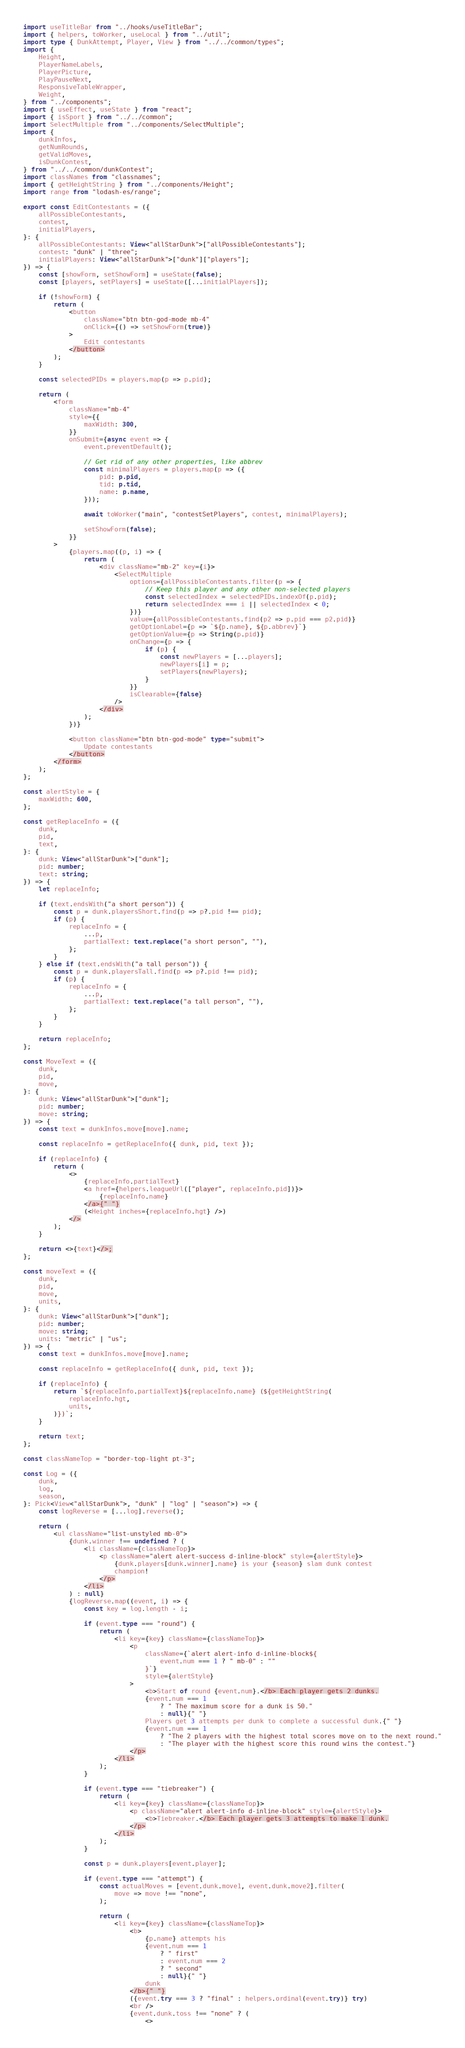<code> <loc_0><loc_0><loc_500><loc_500><_TypeScript_>import useTitleBar from "../hooks/useTitleBar";
import { helpers, toWorker, useLocal } from "../util";
import type { DunkAttempt, Player, View } from "../../common/types";
import {
	Height,
	PlayerNameLabels,
	PlayerPicture,
	PlayPauseNext,
	ResponsiveTableWrapper,
	Weight,
} from "../components";
import { useEffect, useState } from "react";
import { isSport } from "../../common";
import SelectMultiple from "../components/SelectMultiple";
import {
	dunkInfos,
	getNumRounds,
	getValidMoves,
	isDunkContest,
} from "../../common/dunkContest";
import classNames from "classnames";
import { getHeightString } from "../components/Height";
import range from "lodash-es/range";

export const EditContestants = ({
	allPossibleContestants,
	contest,
	initialPlayers,
}: {
	allPossibleContestants: View<"allStarDunk">["allPossibleContestants"];
	contest: "dunk" | "three";
	initialPlayers: View<"allStarDunk">["dunk"]["players"];
}) => {
	const [showForm, setShowForm] = useState(false);
	const [players, setPlayers] = useState([...initialPlayers]);

	if (!showForm) {
		return (
			<button
				className="btn btn-god-mode mb-4"
				onClick={() => setShowForm(true)}
			>
				Edit contestants
			</button>
		);
	}

	const selectedPIDs = players.map(p => p.pid);

	return (
		<form
			className="mb-4"
			style={{
				maxWidth: 300,
			}}
			onSubmit={async event => {
				event.preventDefault();

				// Get rid of any other properties, like abbrev
				const minimalPlayers = players.map(p => ({
					pid: p.pid,
					tid: p.tid,
					name: p.name,
				}));

				await toWorker("main", "contestSetPlayers", contest, minimalPlayers);

				setShowForm(false);
			}}
		>
			{players.map((p, i) => {
				return (
					<div className="mb-2" key={i}>
						<SelectMultiple
							options={allPossibleContestants.filter(p => {
								// Keep this player and any other non-selected players
								const selectedIndex = selectedPIDs.indexOf(p.pid);
								return selectedIndex === i || selectedIndex < 0;
							})}
							value={allPossibleContestants.find(p2 => p.pid === p2.pid)}
							getOptionLabel={p => `${p.name}, ${p.abbrev}`}
							getOptionValue={p => String(p.pid)}
							onChange={p => {
								if (p) {
									const newPlayers = [...players];
									newPlayers[i] = p;
									setPlayers(newPlayers);
								}
							}}
							isClearable={false}
						/>
					</div>
				);
			})}

			<button className="btn btn-god-mode" type="submit">
				Update contestants
			</button>
		</form>
	);
};

const alertStyle = {
	maxWidth: 600,
};

const getReplaceInfo = ({
	dunk,
	pid,
	text,
}: {
	dunk: View<"allStarDunk">["dunk"];
	pid: number;
	text: string;
}) => {
	let replaceInfo;

	if (text.endsWith("a short person")) {
		const p = dunk.playersShort.find(p => p?.pid !== pid);
		if (p) {
			replaceInfo = {
				...p,
				partialText: text.replace("a short person", ""),
			};
		}
	} else if (text.endsWith("a tall person")) {
		const p = dunk.playersTall.find(p => p?.pid !== pid);
		if (p) {
			replaceInfo = {
				...p,
				partialText: text.replace("a tall person", ""),
			};
		}
	}

	return replaceInfo;
};

const MoveText = ({
	dunk,
	pid,
	move,
}: {
	dunk: View<"allStarDunk">["dunk"];
	pid: number;
	move: string;
}) => {
	const text = dunkInfos.move[move].name;

	const replaceInfo = getReplaceInfo({ dunk, pid, text });

	if (replaceInfo) {
		return (
			<>
				{replaceInfo.partialText}
				<a href={helpers.leagueUrl(["player", replaceInfo.pid])}>
					{replaceInfo.name}
				</a>{" "}
				(<Height inches={replaceInfo.hgt} />)
			</>
		);
	}

	return <>{text}</>;
};

const moveText = ({
	dunk,
	pid,
	move,
	units,
}: {
	dunk: View<"allStarDunk">["dunk"];
	pid: number;
	move: string;
	units: "metric" | "us";
}) => {
	const text = dunkInfos.move[move].name;

	const replaceInfo = getReplaceInfo({ dunk, pid, text });

	if (replaceInfo) {
		return `${replaceInfo.partialText}${replaceInfo.name} (${getHeightString(
			replaceInfo.hgt,
			units,
		)})`;
	}

	return text;
};

const classNameTop = "border-top-light pt-3";

const Log = ({
	dunk,
	log,
	season,
}: Pick<View<"allStarDunk">, "dunk" | "log" | "season">) => {
	const logReverse = [...log].reverse();

	return (
		<ul className="list-unstyled mb-0">
			{dunk.winner !== undefined ? (
				<li className={classNameTop}>
					<p className="alert alert-success d-inline-block" style={alertStyle}>
						{dunk.players[dunk.winner].name} is your {season} slam dunk contest
						champion!
					</p>
				</li>
			) : null}
			{logReverse.map((event, i) => {
				const key = log.length - i;

				if (event.type === "round") {
					return (
						<li key={key} className={classNameTop}>
							<p
								className={`alert alert-info d-inline-block${
									event.num === 1 ? " mb-0" : ""
								}`}
								style={alertStyle}
							>
								<b>Start of round {event.num}.</b> Each player gets 2 dunks.
								{event.num === 1
									? " The maximum score for a dunk is 50."
									: null}{" "}
								Players get 3 attempts per dunk to complete a successful dunk.{" "}
								{event.num === 1
									? "The 2 players with the highest total scores move on to the next round."
									: "The player with the highest score this round wins the contest."}
							</p>
						</li>
					);
				}

				if (event.type === "tiebreaker") {
					return (
						<li key={key} className={classNameTop}>
							<p className="alert alert-info d-inline-block" style={alertStyle}>
								<b>Tiebreaker.</b> Each player gets 3 attempts to make 1 dunk.
							</p>
						</li>
					);
				}

				const p = dunk.players[event.player];

				if (event.type === "attempt") {
					const actualMoves = [event.dunk.move1, event.dunk.move2].filter(
						move => move !== "none",
					);

					return (
						<li key={key} className={classNameTop}>
							<b>
								{p.name} attempts his
								{event.num === 1
									? " first"
									: event.num === 2
									? " second"
									: null}{" "}
								dunk
							</b>{" "}
							({event.try === 3 ? "final" : helpers.ordinal(event.try)} try)
							<br />
							{event.dunk.toss !== "none" ? (
								<></code> 